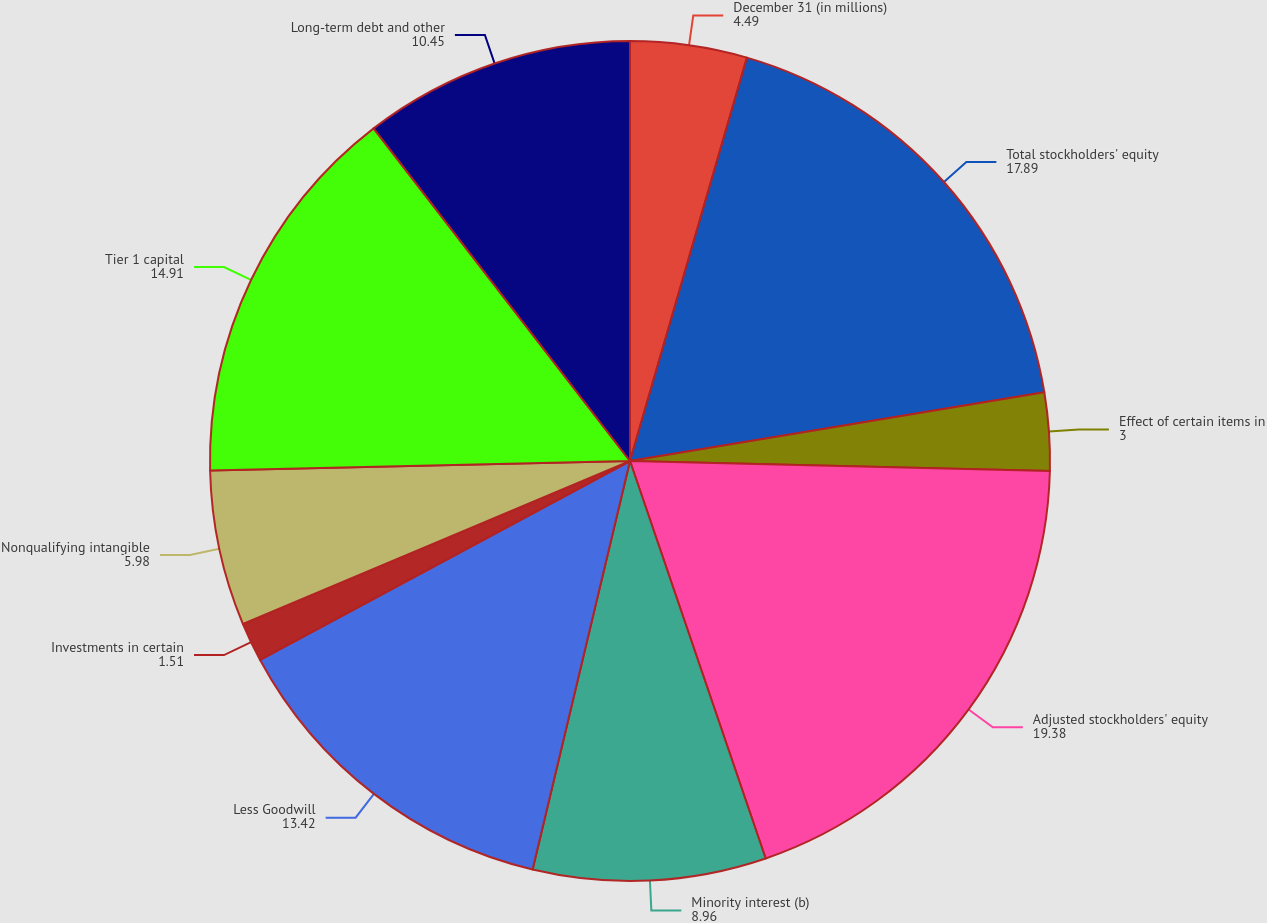<chart> <loc_0><loc_0><loc_500><loc_500><pie_chart><fcel>December 31 (in millions)<fcel>Total stockholders' equity<fcel>Effect of certain items in<fcel>Adjusted stockholders' equity<fcel>Minority interest (b)<fcel>Less Goodwill<fcel>Investments in certain<fcel>Nonqualifying intangible<fcel>Tier 1 capital<fcel>Long-term debt and other<nl><fcel>4.49%<fcel>17.89%<fcel>3.0%<fcel>19.38%<fcel>8.96%<fcel>13.42%<fcel>1.51%<fcel>5.98%<fcel>14.91%<fcel>10.45%<nl></chart> 